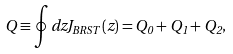<formula> <loc_0><loc_0><loc_500><loc_500>Q \equiv \oint d z J _ { B R S T } ( z ) = Q _ { 0 } + Q _ { 1 } + Q _ { 2 } ,</formula> 